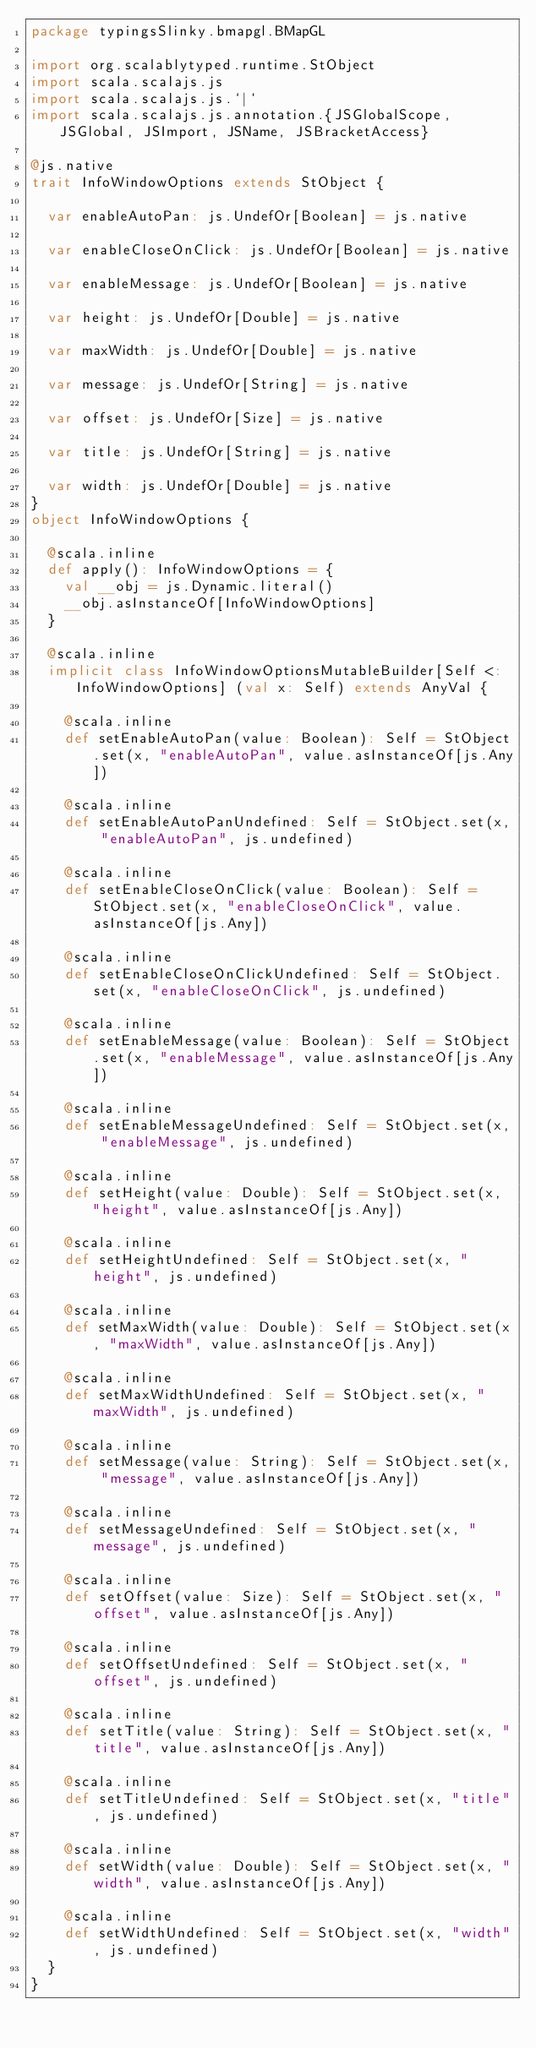Convert code to text. <code><loc_0><loc_0><loc_500><loc_500><_Scala_>package typingsSlinky.bmapgl.BMapGL

import org.scalablytyped.runtime.StObject
import scala.scalajs.js
import scala.scalajs.js.`|`
import scala.scalajs.js.annotation.{JSGlobalScope, JSGlobal, JSImport, JSName, JSBracketAccess}

@js.native
trait InfoWindowOptions extends StObject {
  
  var enableAutoPan: js.UndefOr[Boolean] = js.native
  
  var enableCloseOnClick: js.UndefOr[Boolean] = js.native
  
  var enableMessage: js.UndefOr[Boolean] = js.native
  
  var height: js.UndefOr[Double] = js.native
  
  var maxWidth: js.UndefOr[Double] = js.native
  
  var message: js.UndefOr[String] = js.native
  
  var offset: js.UndefOr[Size] = js.native
  
  var title: js.UndefOr[String] = js.native
  
  var width: js.UndefOr[Double] = js.native
}
object InfoWindowOptions {
  
  @scala.inline
  def apply(): InfoWindowOptions = {
    val __obj = js.Dynamic.literal()
    __obj.asInstanceOf[InfoWindowOptions]
  }
  
  @scala.inline
  implicit class InfoWindowOptionsMutableBuilder[Self <: InfoWindowOptions] (val x: Self) extends AnyVal {
    
    @scala.inline
    def setEnableAutoPan(value: Boolean): Self = StObject.set(x, "enableAutoPan", value.asInstanceOf[js.Any])
    
    @scala.inline
    def setEnableAutoPanUndefined: Self = StObject.set(x, "enableAutoPan", js.undefined)
    
    @scala.inline
    def setEnableCloseOnClick(value: Boolean): Self = StObject.set(x, "enableCloseOnClick", value.asInstanceOf[js.Any])
    
    @scala.inline
    def setEnableCloseOnClickUndefined: Self = StObject.set(x, "enableCloseOnClick", js.undefined)
    
    @scala.inline
    def setEnableMessage(value: Boolean): Self = StObject.set(x, "enableMessage", value.asInstanceOf[js.Any])
    
    @scala.inline
    def setEnableMessageUndefined: Self = StObject.set(x, "enableMessage", js.undefined)
    
    @scala.inline
    def setHeight(value: Double): Self = StObject.set(x, "height", value.asInstanceOf[js.Any])
    
    @scala.inline
    def setHeightUndefined: Self = StObject.set(x, "height", js.undefined)
    
    @scala.inline
    def setMaxWidth(value: Double): Self = StObject.set(x, "maxWidth", value.asInstanceOf[js.Any])
    
    @scala.inline
    def setMaxWidthUndefined: Self = StObject.set(x, "maxWidth", js.undefined)
    
    @scala.inline
    def setMessage(value: String): Self = StObject.set(x, "message", value.asInstanceOf[js.Any])
    
    @scala.inline
    def setMessageUndefined: Self = StObject.set(x, "message", js.undefined)
    
    @scala.inline
    def setOffset(value: Size): Self = StObject.set(x, "offset", value.asInstanceOf[js.Any])
    
    @scala.inline
    def setOffsetUndefined: Self = StObject.set(x, "offset", js.undefined)
    
    @scala.inline
    def setTitle(value: String): Self = StObject.set(x, "title", value.asInstanceOf[js.Any])
    
    @scala.inline
    def setTitleUndefined: Self = StObject.set(x, "title", js.undefined)
    
    @scala.inline
    def setWidth(value: Double): Self = StObject.set(x, "width", value.asInstanceOf[js.Any])
    
    @scala.inline
    def setWidthUndefined: Self = StObject.set(x, "width", js.undefined)
  }
}
</code> 